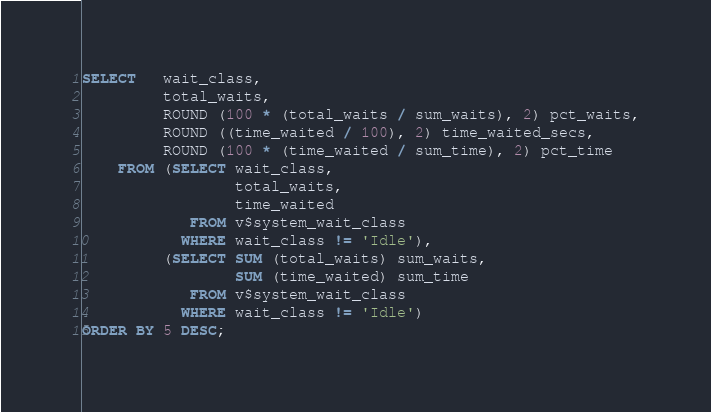Convert code to text. <code><loc_0><loc_0><loc_500><loc_500><_SQL_>SELECT   wait_class,
         total_waits,
         ROUND (100 * (total_waits / sum_waits), 2) pct_waits,
         ROUND ((time_waited / 100), 2) time_waited_secs,
         ROUND (100 * (time_waited / sum_time), 2) pct_time
    FROM (SELECT wait_class,
                 total_waits,
                 time_waited
            FROM v$system_wait_class
           WHERE wait_class != 'Idle'),
         (SELECT SUM (total_waits) sum_waits,
                 SUM (time_waited) sum_time
            FROM v$system_wait_class
           WHERE wait_class != 'Idle')
ORDER BY 5 DESC;</code> 